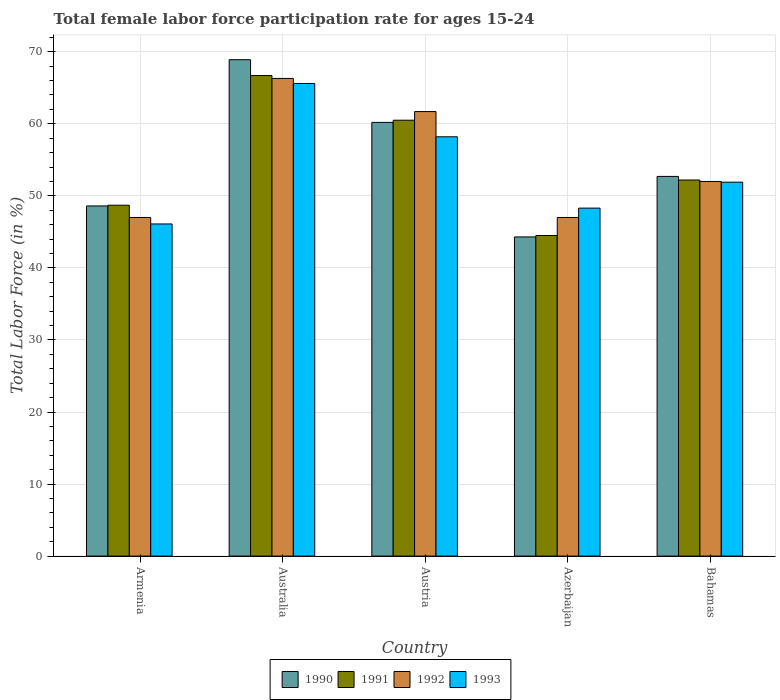How many different coloured bars are there?
Provide a short and direct response. 4. How many groups of bars are there?
Offer a terse response. 5. Are the number of bars per tick equal to the number of legend labels?
Your response must be concise. Yes. Are the number of bars on each tick of the X-axis equal?
Your answer should be very brief. Yes. How many bars are there on the 5th tick from the left?
Give a very brief answer. 4. How many bars are there on the 4th tick from the right?
Offer a very short reply. 4. In how many cases, is the number of bars for a given country not equal to the number of legend labels?
Keep it short and to the point. 0. What is the female labor force participation rate in 1993 in Bahamas?
Your response must be concise. 51.9. Across all countries, what is the maximum female labor force participation rate in 1992?
Offer a very short reply. 66.3. Across all countries, what is the minimum female labor force participation rate in 1991?
Provide a succinct answer. 44.5. In which country was the female labor force participation rate in 1990 maximum?
Offer a very short reply. Australia. In which country was the female labor force participation rate in 1991 minimum?
Give a very brief answer. Azerbaijan. What is the total female labor force participation rate in 1992 in the graph?
Your response must be concise. 274. What is the difference between the female labor force participation rate in 1991 in Armenia and that in Australia?
Make the answer very short. -18. What is the difference between the female labor force participation rate in 1991 in Austria and the female labor force participation rate in 1993 in Armenia?
Provide a short and direct response. 14.4. What is the average female labor force participation rate in 1992 per country?
Make the answer very short. 54.8. What is the ratio of the female labor force participation rate in 1992 in Austria to that in Azerbaijan?
Your answer should be compact. 1.31. Is the female labor force participation rate in 1991 in Australia less than that in Azerbaijan?
Make the answer very short. No. What is the difference between the highest and the second highest female labor force participation rate in 1993?
Offer a terse response. 7.4. What is the difference between the highest and the lowest female labor force participation rate in 1991?
Make the answer very short. 22.2. Is the sum of the female labor force participation rate in 1992 in Azerbaijan and Bahamas greater than the maximum female labor force participation rate in 1993 across all countries?
Offer a very short reply. Yes. Is it the case that in every country, the sum of the female labor force participation rate in 1993 and female labor force participation rate in 1991 is greater than the female labor force participation rate in 1990?
Offer a very short reply. Yes. How many bars are there?
Your answer should be very brief. 20. Are all the bars in the graph horizontal?
Your answer should be very brief. No. Does the graph contain grids?
Offer a very short reply. Yes. What is the title of the graph?
Ensure brevity in your answer.  Total female labor force participation rate for ages 15-24. What is the label or title of the X-axis?
Your answer should be very brief. Country. What is the label or title of the Y-axis?
Offer a terse response. Total Labor Force (in %). What is the Total Labor Force (in %) in 1990 in Armenia?
Your answer should be compact. 48.6. What is the Total Labor Force (in %) of 1991 in Armenia?
Give a very brief answer. 48.7. What is the Total Labor Force (in %) of 1993 in Armenia?
Offer a terse response. 46.1. What is the Total Labor Force (in %) of 1990 in Australia?
Your answer should be very brief. 68.9. What is the Total Labor Force (in %) of 1991 in Australia?
Provide a short and direct response. 66.7. What is the Total Labor Force (in %) in 1992 in Australia?
Your response must be concise. 66.3. What is the Total Labor Force (in %) in 1993 in Australia?
Make the answer very short. 65.6. What is the Total Labor Force (in %) of 1990 in Austria?
Provide a succinct answer. 60.2. What is the Total Labor Force (in %) in 1991 in Austria?
Provide a short and direct response. 60.5. What is the Total Labor Force (in %) in 1992 in Austria?
Offer a terse response. 61.7. What is the Total Labor Force (in %) in 1993 in Austria?
Your answer should be very brief. 58.2. What is the Total Labor Force (in %) of 1990 in Azerbaijan?
Offer a very short reply. 44.3. What is the Total Labor Force (in %) of 1991 in Azerbaijan?
Provide a succinct answer. 44.5. What is the Total Labor Force (in %) of 1993 in Azerbaijan?
Provide a short and direct response. 48.3. What is the Total Labor Force (in %) of 1990 in Bahamas?
Your answer should be very brief. 52.7. What is the Total Labor Force (in %) of 1991 in Bahamas?
Your answer should be compact. 52.2. What is the Total Labor Force (in %) of 1992 in Bahamas?
Keep it short and to the point. 52. What is the Total Labor Force (in %) in 1993 in Bahamas?
Your answer should be compact. 51.9. Across all countries, what is the maximum Total Labor Force (in %) in 1990?
Provide a succinct answer. 68.9. Across all countries, what is the maximum Total Labor Force (in %) in 1991?
Your response must be concise. 66.7. Across all countries, what is the maximum Total Labor Force (in %) of 1992?
Keep it short and to the point. 66.3. Across all countries, what is the maximum Total Labor Force (in %) of 1993?
Your response must be concise. 65.6. Across all countries, what is the minimum Total Labor Force (in %) in 1990?
Provide a short and direct response. 44.3. Across all countries, what is the minimum Total Labor Force (in %) of 1991?
Give a very brief answer. 44.5. Across all countries, what is the minimum Total Labor Force (in %) in 1992?
Provide a succinct answer. 47. Across all countries, what is the minimum Total Labor Force (in %) in 1993?
Offer a very short reply. 46.1. What is the total Total Labor Force (in %) in 1990 in the graph?
Your response must be concise. 274.7. What is the total Total Labor Force (in %) in 1991 in the graph?
Your response must be concise. 272.6. What is the total Total Labor Force (in %) of 1992 in the graph?
Your answer should be very brief. 274. What is the total Total Labor Force (in %) in 1993 in the graph?
Provide a short and direct response. 270.1. What is the difference between the Total Labor Force (in %) in 1990 in Armenia and that in Australia?
Your answer should be very brief. -20.3. What is the difference between the Total Labor Force (in %) in 1992 in Armenia and that in Australia?
Offer a terse response. -19.3. What is the difference between the Total Labor Force (in %) in 1993 in Armenia and that in Australia?
Provide a short and direct response. -19.5. What is the difference between the Total Labor Force (in %) in 1991 in Armenia and that in Austria?
Offer a very short reply. -11.8. What is the difference between the Total Labor Force (in %) in 1992 in Armenia and that in Austria?
Provide a succinct answer. -14.7. What is the difference between the Total Labor Force (in %) in 1992 in Armenia and that in Azerbaijan?
Provide a succinct answer. 0. What is the difference between the Total Labor Force (in %) in 1993 in Armenia and that in Azerbaijan?
Your response must be concise. -2.2. What is the difference between the Total Labor Force (in %) of 1990 in Armenia and that in Bahamas?
Your answer should be very brief. -4.1. What is the difference between the Total Labor Force (in %) in 1993 in Armenia and that in Bahamas?
Keep it short and to the point. -5.8. What is the difference between the Total Labor Force (in %) of 1990 in Australia and that in Austria?
Offer a terse response. 8.7. What is the difference between the Total Labor Force (in %) in 1991 in Australia and that in Austria?
Ensure brevity in your answer.  6.2. What is the difference between the Total Labor Force (in %) of 1993 in Australia and that in Austria?
Offer a terse response. 7.4. What is the difference between the Total Labor Force (in %) of 1990 in Australia and that in Azerbaijan?
Offer a terse response. 24.6. What is the difference between the Total Labor Force (in %) of 1992 in Australia and that in Azerbaijan?
Keep it short and to the point. 19.3. What is the difference between the Total Labor Force (in %) of 1990 in Australia and that in Bahamas?
Your answer should be very brief. 16.2. What is the difference between the Total Labor Force (in %) of 1992 in Australia and that in Bahamas?
Offer a very short reply. 14.3. What is the difference between the Total Labor Force (in %) of 1992 in Austria and that in Azerbaijan?
Keep it short and to the point. 14.7. What is the difference between the Total Labor Force (in %) in 1993 in Austria and that in Azerbaijan?
Provide a succinct answer. 9.9. What is the difference between the Total Labor Force (in %) of 1990 in Austria and that in Bahamas?
Your response must be concise. 7.5. What is the difference between the Total Labor Force (in %) in 1991 in Austria and that in Bahamas?
Your response must be concise. 8.3. What is the difference between the Total Labor Force (in %) of 1992 in Austria and that in Bahamas?
Offer a terse response. 9.7. What is the difference between the Total Labor Force (in %) in 1993 in Austria and that in Bahamas?
Offer a very short reply. 6.3. What is the difference between the Total Labor Force (in %) in 1992 in Azerbaijan and that in Bahamas?
Keep it short and to the point. -5. What is the difference between the Total Labor Force (in %) of 1990 in Armenia and the Total Labor Force (in %) of 1991 in Australia?
Offer a very short reply. -18.1. What is the difference between the Total Labor Force (in %) of 1990 in Armenia and the Total Labor Force (in %) of 1992 in Australia?
Your answer should be very brief. -17.7. What is the difference between the Total Labor Force (in %) in 1990 in Armenia and the Total Labor Force (in %) in 1993 in Australia?
Make the answer very short. -17. What is the difference between the Total Labor Force (in %) of 1991 in Armenia and the Total Labor Force (in %) of 1992 in Australia?
Make the answer very short. -17.6. What is the difference between the Total Labor Force (in %) of 1991 in Armenia and the Total Labor Force (in %) of 1993 in Australia?
Your answer should be very brief. -16.9. What is the difference between the Total Labor Force (in %) of 1992 in Armenia and the Total Labor Force (in %) of 1993 in Australia?
Your answer should be very brief. -18.6. What is the difference between the Total Labor Force (in %) of 1990 in Armenia and the Total Labor Force (in %) of 1993 in Austria?
Provide a short and direct response. -9.6. What is the difference between the Total Labor Force (in %) of 1991 in Armenia and the Total Labor Force (in %) of 1992 in Austria?
Make the answer very short. -13. What is the difference between the Total Labor Force (in %) of 1991 in Armenia and the Total Labor Force (in %) of 1993 in Austria?
Provide a short and direct response. -9.5. What is the difference between the Total Labor Force (in %) of 1990 in Armenia and the Total Labor Force (in %) of 1991 in Azerbaijan?
Make the answer very short. 4.1. What is the difference between the Total Labor Force (in %) in 1990 in Armenia and the Total Labor Force (in %) in 1993 in Azerbaijan?
Provide a short and direct response. 0.3. What is the difference between the Total Labor Force (in %) in 1991 in Armenia and the Total Labor Force (in %) in 1992 in Azerbaijan?
Offer a very short reply. 1.7. What is the difference between the Total Labor Force (in %) of 1991 in Armenia and the Total Labor Force (in %) of 1993 in Azerbaijan?
Give a very brief answer. 0.4. What is the difference between the Total Labor Force (in %) in 1992 in Armenia and the Total Labor Force (in %) in 1993 in Azerbaijan?
Keep it short and to the point. -1.3. What is the difference between the Total Labor Force (in %) in 1990 in Armenia and the Total Labor Force (in %) in 1991 in Bahamas?
Your answer should be compact. -3.6. What is the difference between the Total Labor Force (in %) in 1990 in Armenia and the Total Labor Force (in %) in 1993 in Bahamas?
Offer a very short reply. -3.3. What is the difference between the Total Labor Force (in %) in 1991 in Armenia and the Total Labor Force (in %) in 1992 in Bahamas?
Your response must be concise. -3.3. What is the difference between the Total Labor Force (in %) of 1991 in Armenia and the Total Labor Force (in %) of 1993 in Bahamas?
Provide a short and direct response. -3.2. What is the difference between the Total Labor Force (in %) in 1990 in Australia and the Total Labor Force (in %) in 1992 in Austria?
Your answer should be very brief. 7.2. What is the difference between the Total Labor Force (in %) in 1992 in Australia and the Total Labor Force (in %) in 1993 in Austria?
Ensure brevity in your answer.  8.1. What is the difference between the Total Labor Force (in %) of 1990 in Australia and the Total Labor Force (in %) of 1991 in Azerbaijan?
Ensure brevity in your answer.  24.4. What is the difference between the Total Labor Force (in %) of 1990 in Australia and the Total Labor Force (in %) of 1992 in Azerbaijan?
Your answer should be compact. 21.9. What is the difference between the Total Labor Force (in %) of 1990 in Australia and the Total Labor Force (in %) of 1993 in Azerbaijan?
Offer a terse response. 20.6. What is the difference between the Total Labor Force (in %) of 1991 in Australia and the Total Labor Force (in %) of 1993 in Azerbaijan?
Offer a terse response. 18.4. What is the difference between the Total Labor Force (in %) of 1992 in Australia and the Total Labor Force (in %) of 1993 in Azerbaijan?
Keep it short and to the point. 18. What is the difference between the Total Labor Force (in %) of 1990 in Australia and the Total Labor Force (in %) of 1991 in Bahamas?
Make the answer very short. 16.7. What is the difference between the Total Labor Force (in %) in 1991 in Australia and the Total Labor Force (in %) in 1992 in Bahamas?
Provide a succinct answer. 14.7. What is the difference between the Total Labor Force (in %) in 1991 in Australia and the Total Labor Force (in %) in 1993 in Bahamas?
Ensure brevity in your answer.  14.8. What is the difference between the Total Labor Force (in %) in 1992 in Australia and the Total Labor Force (in %) in 1993 in Bahamas?
Your answer should be very brief. 14.4. What is the difference between the Total Labor Force (in %) in 1990 in Austria and the Total Labor Force (in %) in 1993 in Azerbaijan?
Keep it short and to the point. 11.9. What is the difference between the Total Labor Force (in %) of 1990 in Austria and the Total Labor Force (in %) of 1992 in Bahamas?
Offer a very short reply. 8.2. What is the difference between the Total Labor Force (in %) in 1990 in Austria and the Total Labor Force (in %) in 1993 in Bahamas?
Provide a short and direct response. 8.3. What is the difference between the Total Labor Force (in %) in 1991 in Austria and the Total Labor Force (in %) in 1992 in Bahamas?
Give a very brief answer. 8.5. What is the difference between the Total Labor Force (in %) in 1991 in Austria and the Total Labor Force (in %) in 1993 in Bahamas?
Your response must be concise. 8.6. What is the difference between the Total Labor Force (in %) in 1992 in Austria and the Total Labor Force (in %) in 1993 in Bahamas?
Offer a terse response. 9.8. What is the difference between the Total Labor Force (in %) of 1990 in Azerbaijan and the Total Labor Force (in %) of 1991 in Bahamas?
Ensure brevity in your answer.  -7.9. What is the difference between the Total Labor Force (in %) in 1990 in Azerbaijan and the Total Labor Force (in %) in 1993 in Bahamas?
Your answer should be very brief. -7.6. What is the difference between the Total Labor Force (in %) in 1991 in Azerbaijan and the Total Labor Force (in %) in 1993 in Bahamas?
Provide a succinct answer. -7.4. What is the average Total Labor Force (in %) of 1990 per country?
Your answer should be compact. 54.94. What is the average Total Labor Force (in %) of 1991 per country?
Provide a short and direct response. 54.52. What is the average Total Labor Force (in %) in 1992 per country?
Give a very brief answer. 54.8. What is the average Total Labor Force (in %) of 1993 per country?
Give a very brief answer. 54.02. What is the difference between the Total Labor Force (in %) of 1990 and Total Labor Force (in %) of 1992 in Armenia?
Provide a succinct answer. 1.6. What is the difference between the Total Labor Force (in %) of 1990 and Total Labor Force (in %) of 1993 in Armenia?
Your answer should be compact. 2.5. What is the difference between the Total Labor Force (in %) of 1991 and Total Labor Force (in %) of 1992 in Armenia?
Ensure brevity in your answer.  1.7. What is the difference between the Total Labor Force (in %) in 1990 and Total Labor Force (in %) in 1991 in Austria?
Offer a terse response. -0.3. What is the difference between the Total Labor Force (in %) in 1990 and Total Labor Force (in %) in 1992 in Austria?
Ensure brevity in your answer.  -1.5. What is the difference between the Total Labor Force (in %) in 1990 and Total Labor Force (in %) in 1993 in Austria?
Offer a terse response. 2. What is the difference between the Total Labor Force (in %) in 1991 and Total Labor Force (in %) in 1992 in Austria?
Give a very brief answer. -1.2. What is the difference between the Total Labor Force (in %) in 1992 and Total Labor Force (in %) in 1993 in Austria?
Offer a very short reply. 3.5. What is the difference between the Total Labor Force (in %) in 1990 and Total Labor Force (in %) in 1991 in Azerbaijan?
Your answer should be compact. -0.2. What is the difference between the Total Labor Force (in %) of 1990 and Total Labor Force (in %) of 1992 in Azerbaijan?
Give a very brief answer. -2.7. What is the difference between the Total Labor Force (in %) in 1991 and Total Labor Force (in %) in 1992 in Azerbaijan?
Give a very brief answer. -2.5. What is the difference between the Total Labor Force (in %) in 1990 and Total Labor Force (in %) in 1991 in Bahamas?
Your response must be concise. 0.5. What is the difference between the Total Labor Force (in %) in 1991 and Total Labor Force (in %) in 1992 in Bahamas?
Your answer should be very brief. 0.2. What is the ratio of the Total Labor Force (in %) in 1990 in Armenia to that in Australia?
Your response must be concise. 0.71. What is the ratio of the Total Labor Force (in %) in 1991 in Armenia to that in Australia?
Offer a very short reply. 0.73. What is the ratio of the Total Labor Force (in %) in 1992 in Armenia to that in Australia?
Give a very brief answer. 0.71. What is the ratio of the Total Labor Force (in %) of 1993 in Armenia to that in Australia?
Your answer should be compact. 0.7. What is the ratio of the Total Labor Force (in %) in 1990 in Armenia to that in Austria?
Your answer should be compact. 0.81. What is the ratio of the Total Labor Force (in %) in 1991 in Armenia to that in Austria?
Make the answer very short. 0.81. What is the ratio of the Total Labor Force (in %) of 1992 in Armenia to that in Austria?
Keep it short and to the point. 0.76. What is the ratio of the Total Labor Force (in %) in 1993 in Armenia to that in Austria?
Give a very brief answer. 0.79. What is the ratio of the Total Labor Force (in %) in 1990 in Armenia to that in Azerbaijan?
Offer a very short reply. 1.1. What is the ratio of the Total Labor Force (in %) of 1991 in Armenia to that in Azerbaijan?
Keep it short and to the point. 1.09. What is the ratio of the Total Labor Force (in %) in 1992 in Armenia to that in Azerbaijan?
Your answer should be compact. 1. What is the ratio of the Total Labor Force (in %) in 1993 in Armenia to that in Azerbaijan?
Provide a short and direct response. 0.95. What is the ratio of the Total Labor Force (in %) of 1990 in Armenia to that in Bahamas?
Provide a short and direct response. 0.92. What is the ratio of the Total Labor Force (in %) in 1991 in Armenia to that in Bahamas?
Provide a succinct answer. 0.93. What is the ratio of the Total Labor Force (in %) of 1992 in Armenia to that in Bahamas?
Give a very brief answer. 0.9. What is the ratio of the Total Labor Force (in %) of 1993 in Armenia to that in Bahamas?
Provide a short and direct response. 0.89. What is the ratio of the Total Labor Force (in %) of 1990 in Australia to that in Austria?
Ensure brevity in your answer.  1.14. What is the ratio of the Total Labor Force (in %) of 1991 in Australia to that in Austria?
Make the answer very short. 1.1. What is the ratio of the Total Labor Force (in %) in 1992 in Australia to that in Austria?
Your response must be concise. 1.07. What is the ratio of the Total Labor Force (in %) in 1993 in Australia to that in Austria?
Your answer should be very brief. 1.13. What is the ratio of the Total Labor Force (in %) of 1990 in Australia to that in Azerbaijan?
Offer a very short reply. 1.56. What is the ratio of the Total Labor Force (in %) in 1991 in Australia to that in Azerbaijan?
Provide a succinct answer. 1.5. What is the ratio of the Total Labor Force (in %) of 1992 in Australia to that in Azerbaijan?
Provide a succinct answer. 1.41. What is the ratio of the Total Labor Force (in %) in 1993 in Australia to that in Azerbaijan?
Make the answer very short. 1.36. What is the ratio of the Total Labor Force (in %) in 1990 in Australia to that in Bahamas?
Provide a short and direct response. 1.31. What is the ratio of the Total Labor Force (in %) of 1991 in Australia to that in Bahamas?
Provide a short and direct response. 1.28. What is the ratio of the Total Labor Force (in %) of 1992 in Australia to that in Bahamas?
Your response must be concise. 1.27. What is the ratio of the Total Labor Force (in %) of 1993 in Australia to that in Bahamas?
Provide a succinct answer. 1.26. What is the ratio of the Total Labor Force (in %) in 1990 in Austria to that in Azerbaijan?
Provide a succinct answer. 1.36. What is the ratio of the Total Labor Force (in %) of 1991 in Austria to that in Azerbaijan?
Provide a short and direct response. 1.36. What is the ratio of the Total Labor Force (in %) of 1992 in Austria to that in Azerbaijan?
Provide a succinct answer. 1.31. What is the ratio of the Total Labor Force (in %) in 1993 in Austria to that in Azerbaijan?
Give a very brief answer. 1.21. What is the ratio of the Total Labor Force (in %) of 1990 in Austria to that in Bahamas?
Ensure brevity in your answer.  1.14. What is the ratio of the Total Labor Force (in %) in 1991 in Austria to that in Bahamas?
Your answer should be compact. 1.16. What is the ratio of the Total Labor Force (in %) in 1992 in Austria to that in Bahamas?
Keep it short and to the point. 1.19. What is the ratio of the Total Labor Force (in %) of 1993 in Austria to that in Bahamas?
Your answer should be compact. 1.12. What is the ratio of the Total Labor Force (in %) in 1990 in Azerbaijan to that in Bahamas?
Keep it short and to the point. 0.84. What is the ratio of the Total Labor Force (in %) in 1991 in Azerbaijan to that in Bahamas?
Provide a succinct answer. 0.85. What is the ratio of the Total Labor Force (in %) of 1992 in Azerbaijan to that in Bahamas?
Make the answer very short. 0.9. What is the ratio of the Total Labor Force (in %) of 1993 in Azerbaijan to that in Bahamas?
Your answer should be compact. 0.93. What is the difference between the highest and the second highest Total Labor Force (in %) in 1991?
Give a very brief answer. 6.2. What is the difference between the highest and the second highest Total Labor Force (in %) of 1993?
Your response must be concise. 7.4. What is the difference between the highest and the lowest Total Labor Force (in %) in 1990?
Provide a succinct answer. 24.6. What is the difference between the highest and the lowest Total Labor Force (in %) of 1992?
Make the answer very short. 19.3. 